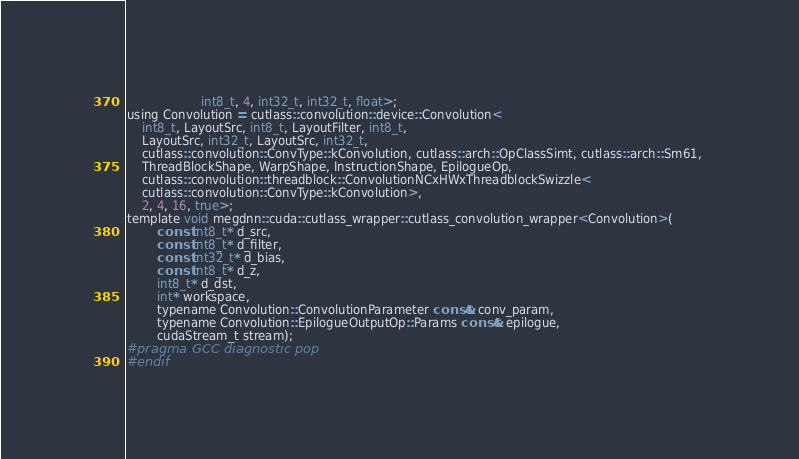<code> <loc_0><loc_0><loc_500><loc_500><_Cuda_>                    int8_t, 4, int32_t, int32_t, float>;
using Convolution = cutlass::convolution::device::Convolution<
    int8_t, LayoutSrc, int8_t, LayoutFilter, int8_t, 
    LayoutSrc, int32_t, LayoutSrc, int32_t, 
    cutlass::convolution::ConvType::kConvolution, cutlass::arch::OpClassSimt, cutlass::arch::Sm61, 
    ThreadBlockShape, WarpShape, InstructionShape, EpilogueOp, 
    cutlass::convolution::threadblock::ConvolutionNCxHWxThreadblockSwizzle<
    cutlass::convolution::ConvType::kConvolution>, 
    2, 4, 16, true>;
template void megdnn::cuda::cutlass_wrapper::cutlass_convolution_wrapper<Convolution>(
        const int8_t* d_src, 
        const int8_t* d_filter, 
        const int32_t* d_bias, 
        const int8_t* d_z, 
        int8_t* d_dst, 
        int* workspace, 
        typename Convolution::ConvolutionParameter const& conv_param, 
        typename Convolution::EpilogueOutputOp::Params const& epilogue, 
        cudaStream_t stream);
#pragma GCC diagnostic pop
#endif
</code> 